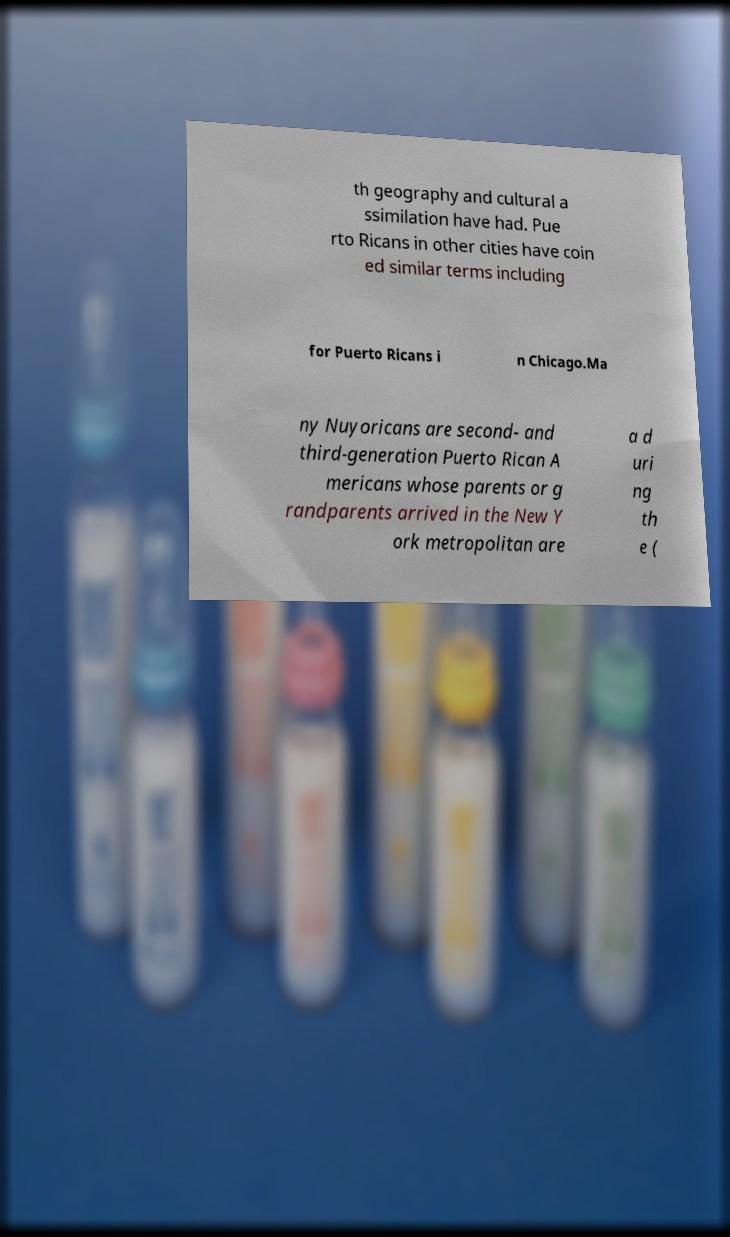Could you assist in decoding the text presented in this image and type it out clearly? th geography and cultural a ssimilation have had. Pue rto Ricans in other cities have coin ed similar terms including for Puerto Ricans i n Chicago.Ma ny Nuyoricans are second- and third-generation Puerto Rican A mericans whose parents or g randparents arrived in the New Y ork metropolitan are a d uri ng th e ( 